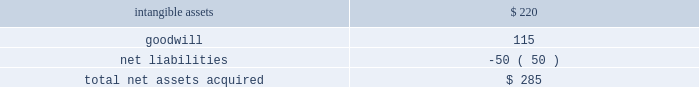News corporation notes to the consolidated financial statements consideration over the fair value of the net tangible and intangible assets acquired was recorded as goodwill .
The allocation is as follows ( in millions ) : assets acquired: .
The acquired intangible assets primarily relate to broadcast licenses , which have a fair value of approximately $ 185 million , tradenames , which have a fair value of approximately $ 27 million , and customer relationships with a fair value of approximately $ 8 million .
The broadcast licenses and tradenames have indefinite lives and the customer relationships are being amortized over a weighted-average useful life of approximately 6 years .
Wireless group 2019s results are included within the news and information services segment , and it is considered a separate reporting unit for purposes of the company 2019s annual goodwill impairment review .
Rea group european business in december 2016 , rea group , in which the company holds a 61.6% ( 61.6 % ) interest , sold its european business for approximately $ 140 million ( approximately 20ac133 million ) in cash , which resulted in a pre-tax gain of $ 107 million for the fiscal year ended june 30 , 2017 .
The sale allows rea group to focus on its core businesses in australia and asia .
In addition to the acquisitions noted above and the investments referenced in note 6 2014investments , the company used $ 62 million of cash for additional acquisitions during fiscal 2017 , primarily consisting of australian regional media ( 201carm 201d ) .
Arm 2019s results are included within the news and information services segment .
Note 5 .
Restructuring programs the company recorded restructuring charges of $ 92 million , $ 71 million and $ 142 million for the fiscal years ended june 30 , 2019 , 2018 and 2017 , respectively , of which $ 77 million , $ 58 million and $ 133 million related to the news and information services segment , respectively .
The restructuring charges recorded in fiscal 2019 , 2018 and 2017 were primarily for employee termination benefits. .
What percent of total net assets acquired was goodwill? 
Computations: (115 / 285)
Answer: 0.40351. 